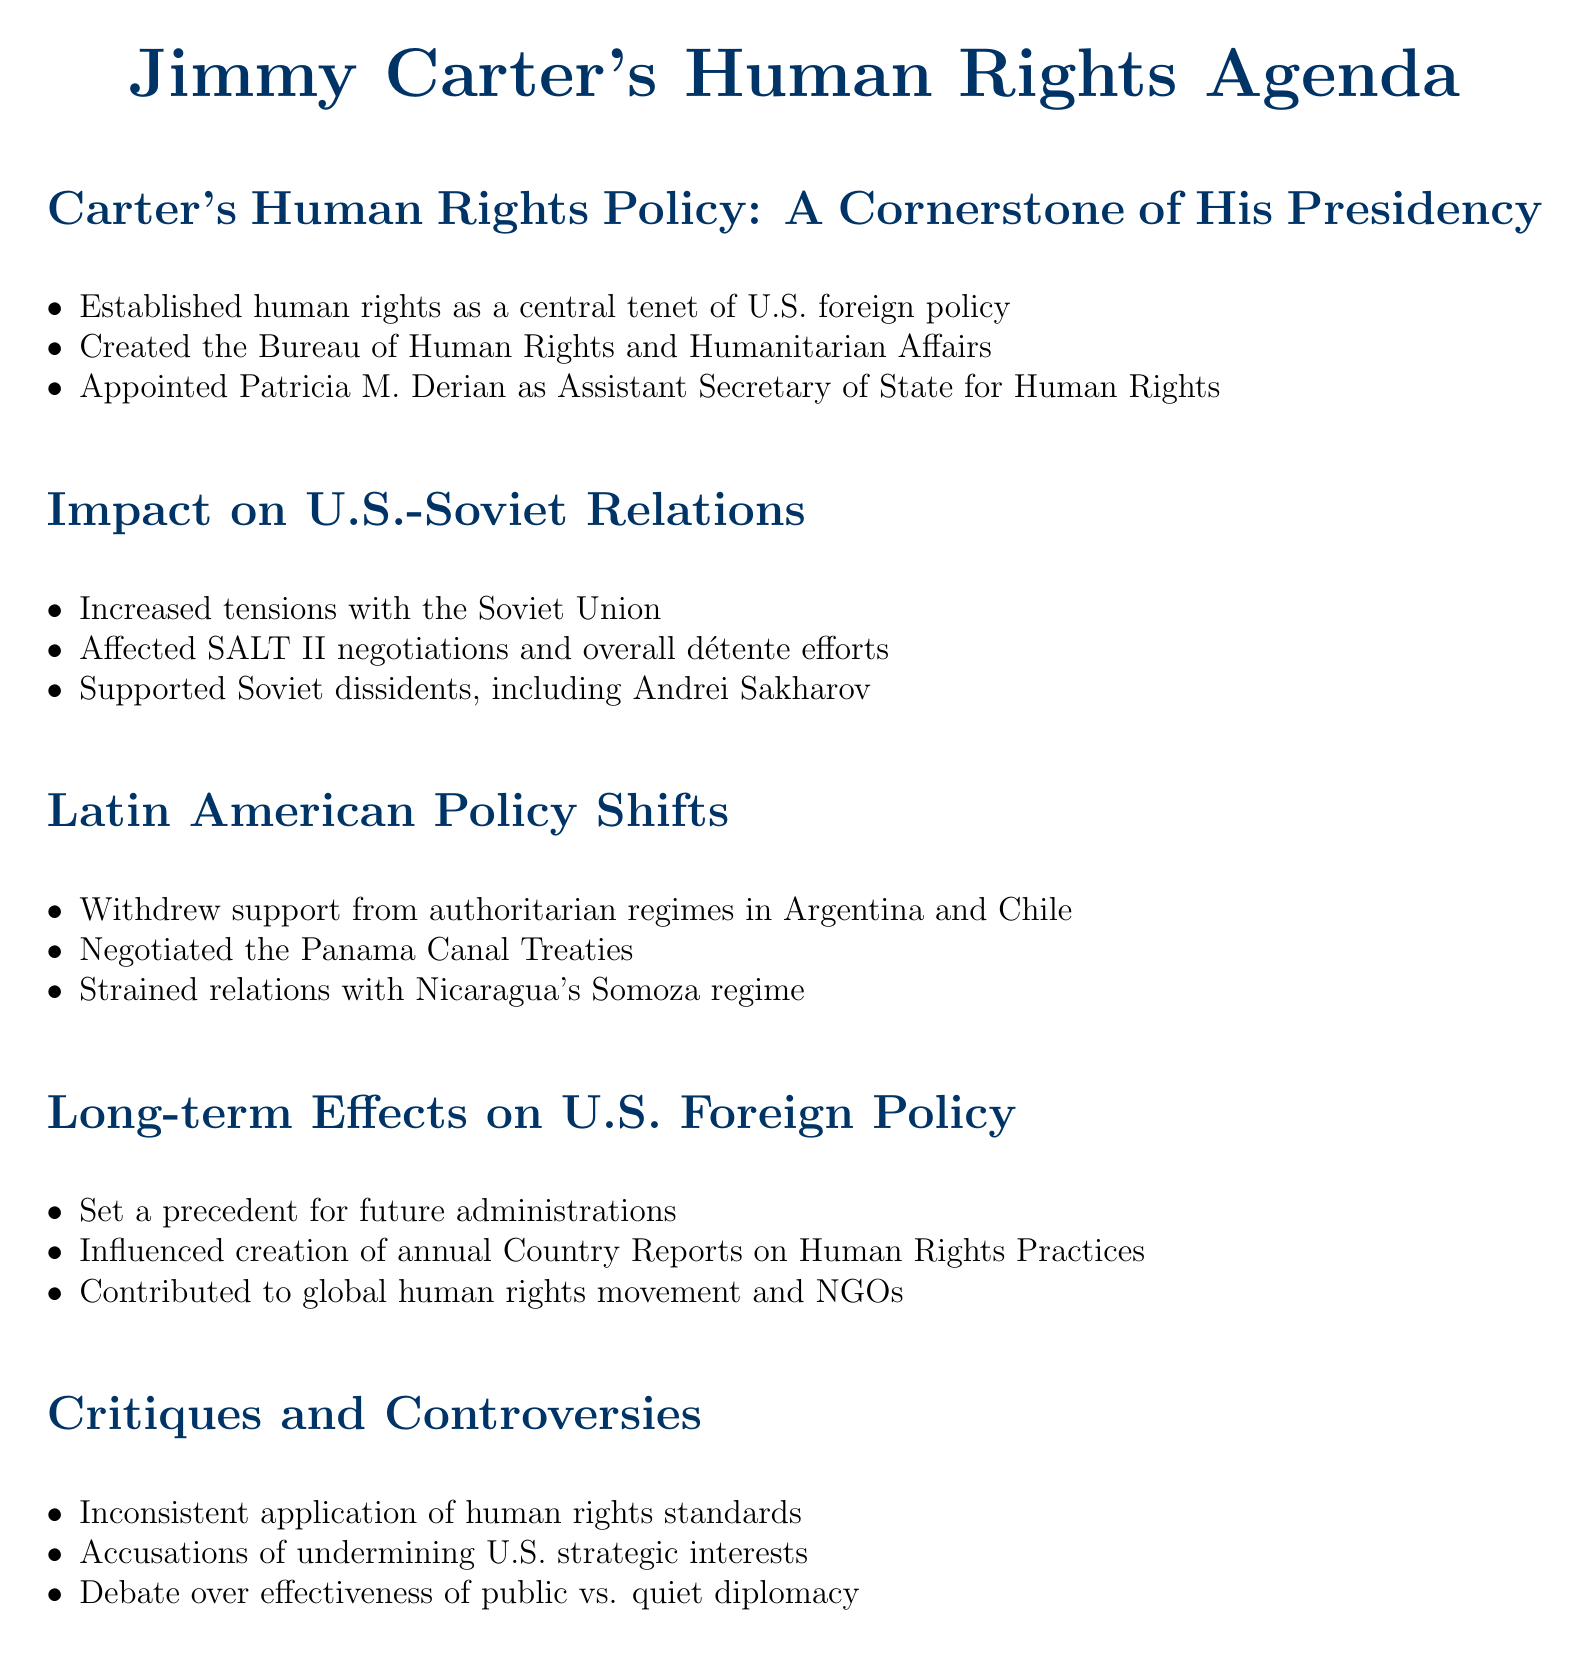What was established as a central tenet of U.S. foreign policy? The document states that human rights were established as a central tenet of U.S. foreign policy during Carter's presidency.
Answer: human rights Who was appointed as Assistant Secretary of State for Human Rights? The document identifies Patricia M. Derian as the individual appointed to this position.
Answer: Patricia M. Derian What impact did Carter's human rights policy have on the SALT II negotiations? The document mentions that the human rights policy affected the SALT II negotiations, suggesting it had a negative impact.
Answer: Affected Which authoritarian regimes did Carter's administration withdraw support from? The document lists Argentina and Chile as the authoritarian regimes from which support was withdrawn.
Answer: Argentina and Chile What long-term effect did Carter's human rights agenda have on U.S. foreign policy? One of the long-term effects mentioned is the setting of a precedent for future administrations regarding human rights.
Answer: Set a precedent What was one critique of Carter's human rights policy? The document notes that there were accusations of inconsistent application of human rights standards.
Answer: Inconsistent application What organization was influenced by Carter's human rights agenda? The document mentions that NGOs, particularly Human Rights Watch, were contributed to by the global human rights movement initiated during Carter's presidency.
Answer: Human Rights Watch How did Carter's policy affect U.S. relations with the Soviet Union? According to the document, tensions increased with the Soviet Union due to criticism of their human rights record.
Answer: Increased tensions 